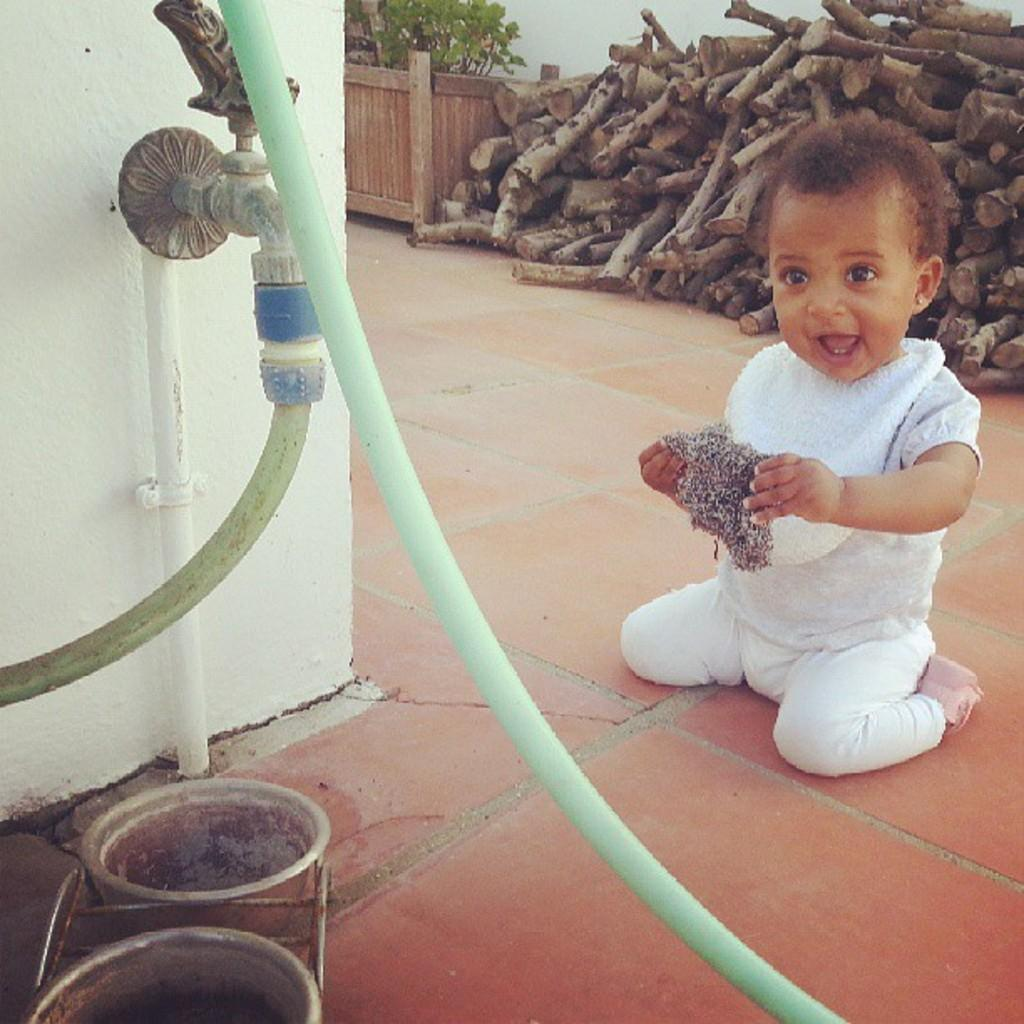What is the kid holding in the image? There is a kid holding an object in the image. What can be seen near the kid in the image? There is a tap in the image. What else is present in the image besides the kid and the tap? There are pipes in the image. What can be seen in the background of the image? There is a plant and wooden logs in the background of the image. What type of oatmeal is being stored in the jar in the image? There is no jar present in the image, so it is not possible to determine if any oatmeal is being stored. 